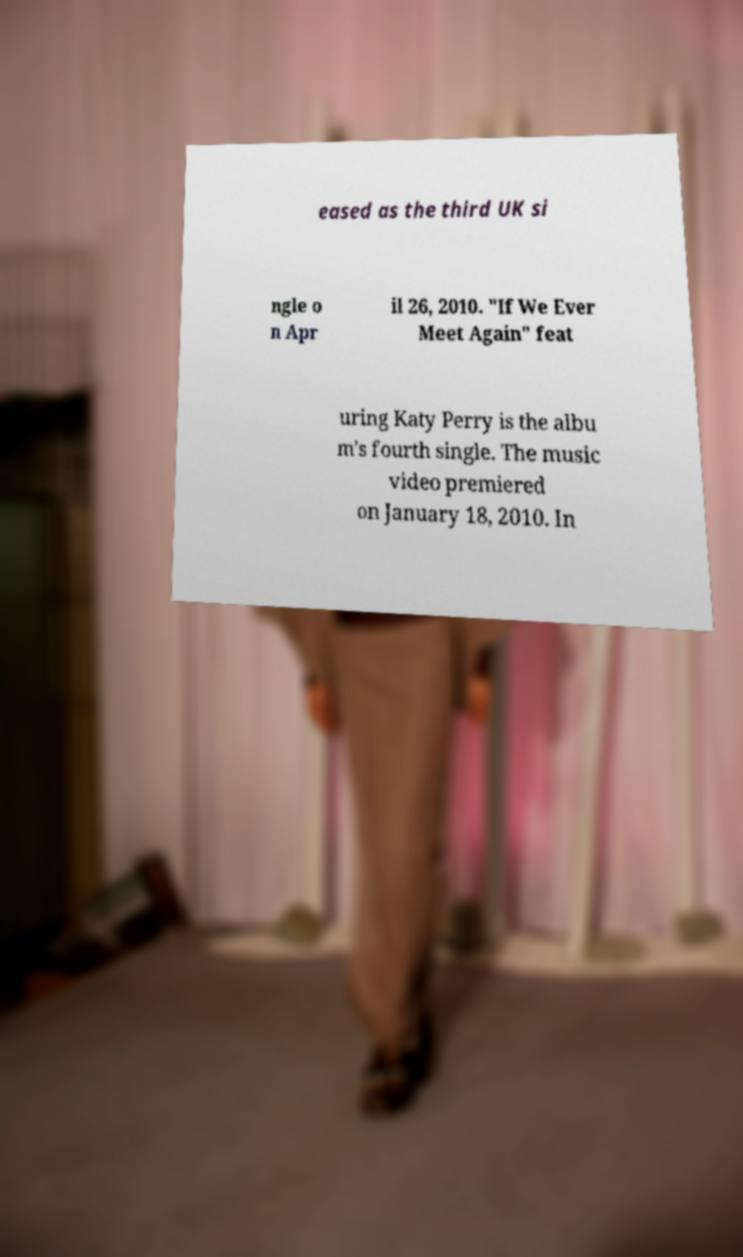Can you accurately transcribe the text from the provided image for me? eased as the third UK si ngle o n Apr il 26, 2010. "If We Ever Meet Again" feat uring Katy Perry is the albu m's fourth single. The music video premiered on January 18, 2010. In 